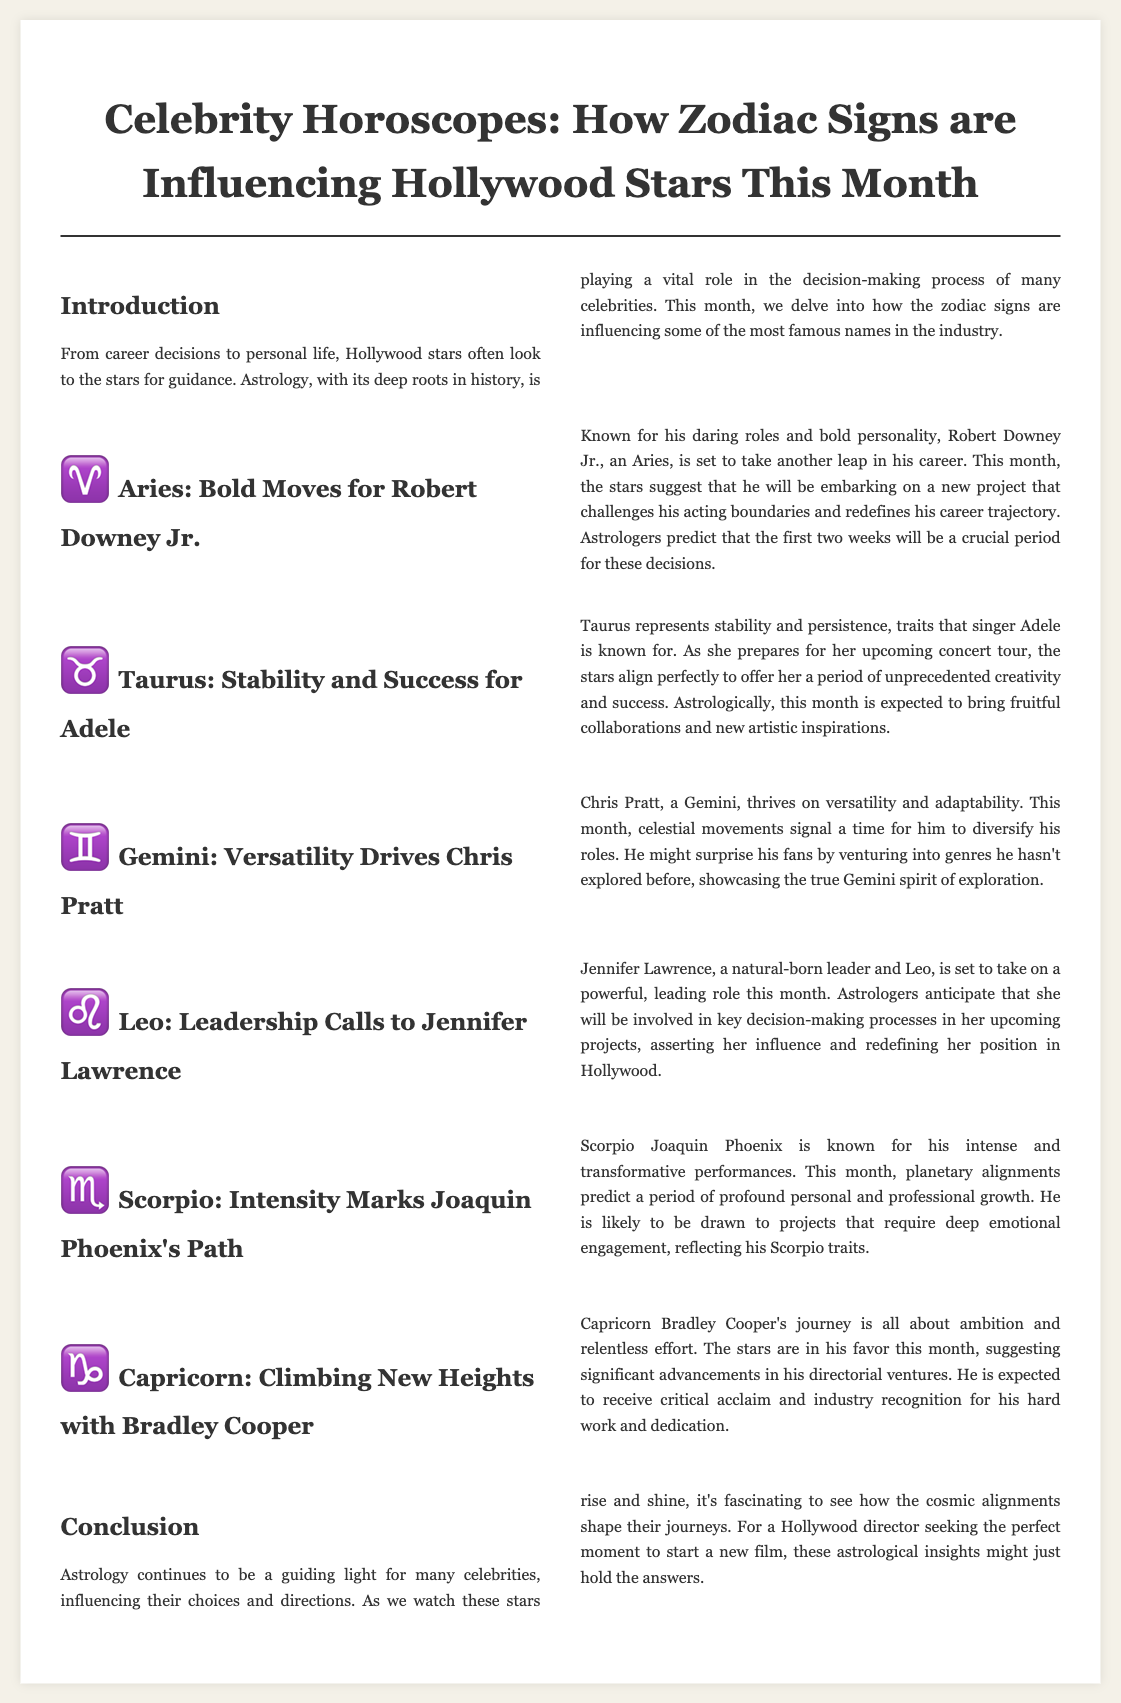what zodiac sign is Robert Downey Jr.? The document identifies Robert Downey Jr. as an Aries, which is indicated in the section title.
Answer: Aries what is Jennifer Lawrence's role this month? The document states that Jennifer Lawrence is set to take on a powerful, leading role this month.
Answer: Leading role which celebrity is expected to experience profound personal growth? The text mentions that Joaquin Phoenix is predicted to experience a period of profound personal and professional growth.
Answer: Joaquin Phoenix what trait does Taurus represent? The document highlights that Taurus represents stability and persistence.
Answer: Stability and persistence what does Chris Pratt plan to do this month? The document states that Chris Pratt will likely diversify his roles, hinting at venturing into new genres.
Answer: Diversify his roles 